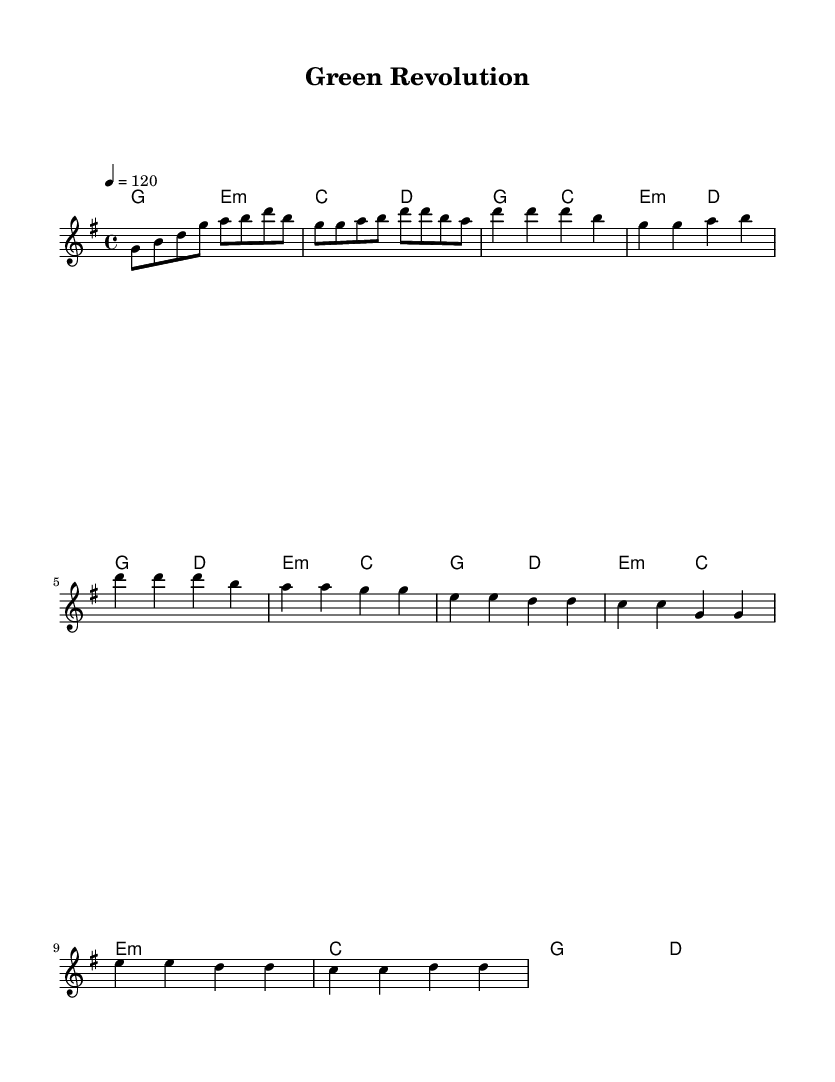What is the key signature of this music? The key signature is G major, which has one sharp (F#). This can be identified by looking at the beginning of the staff where the key signature is indicated.
Answer: G major What is the time signature of this music? The time signature is 4/4, which is indicated right after the key signature. It shows that there are four beats in each measure, and the quarter note receives one beat.
Answer: 4/4 What is the tempo marking of this piece? The tempo marking is 120 beats per minute, which is indicated in the piece and instructs the performer on how fast to play.
Answer: 120 How many measures are in the verse section? The verse section has 4 measures, which can be counted by examining the notation under the "Verse 1" label. Each line contains two measures of music, totaling to four.
Answer: 4 What chord follows G in the chorus? The chord that follows G in the chorus is D. This can be seen by looking at the chord changes listed underneath the melody line during the chorus section.
Answer: D How does the melody in the bridge differ from the verse? The melody in the bridge consists of higher pitches and a different rhythmic pattern compared to the verse, indicating a contrast or shift in the music. This can be understood by comparing the pitches and rhythms between the two sections in the score.
Answer: Higher pitches What musical genre does this piece represent? This piece represents the Hip Hop genre, as it is an upbeat track that celebrates scientific breakthroughs, which aligns with the key themes and rhythms typically found in Hip Hop music.
Answer: Hip Hop 